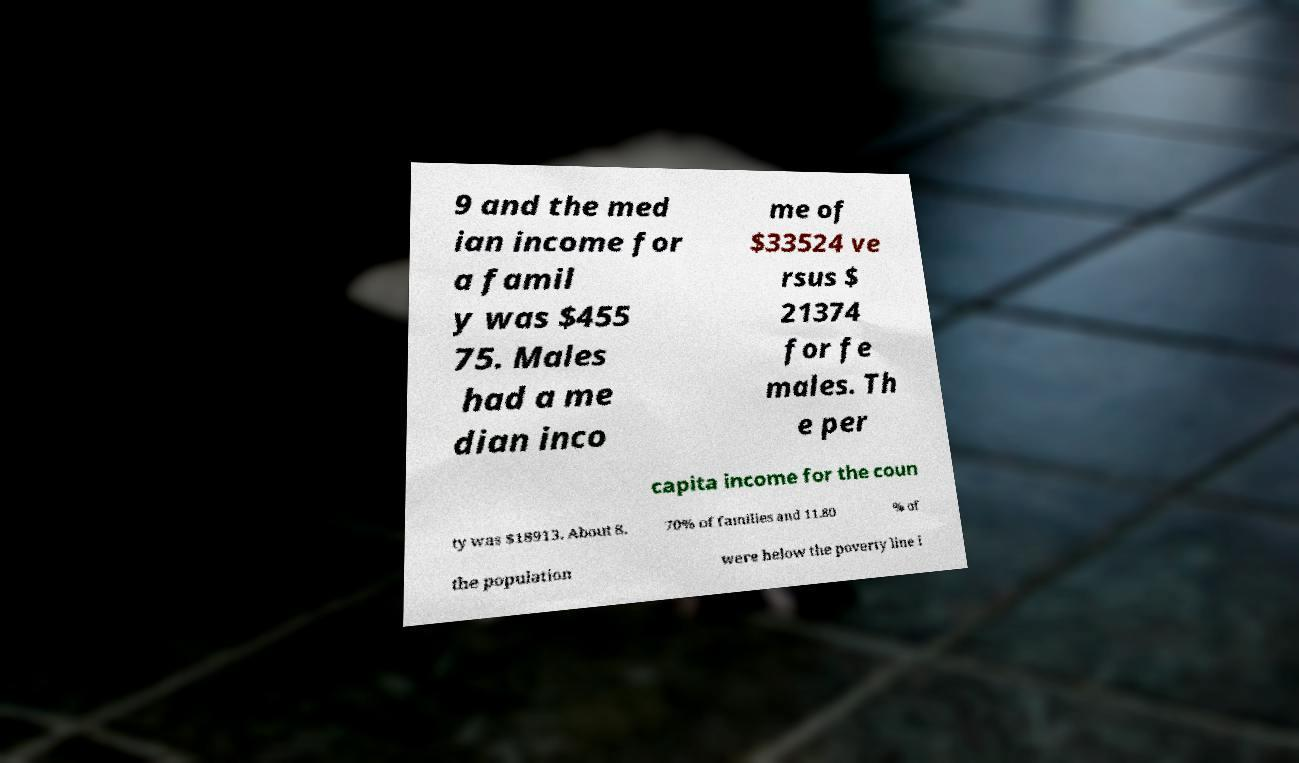Can you accurately transcribe the text from the provided image for me? 9 and the med ian income for a famil y was $455 75. Males had a me dian inco me of $33524 ve rsus $ 21374 for fe males. Th e per capita income for the coun ty was $18913. About 8. 70% of families and 11.80 % of the population were below the poverty line i 